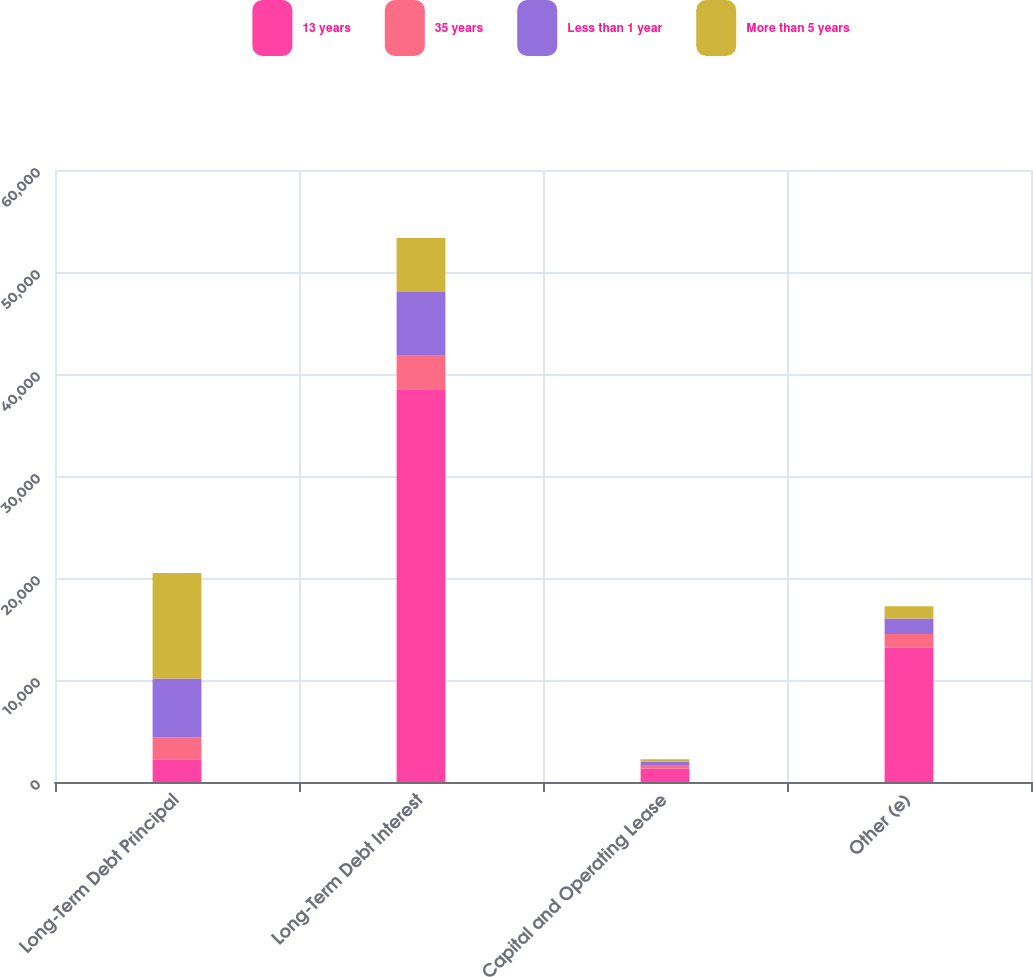Convert chart. <chart><loc_0><loc_0><loc_500><loc_500><stacked_bar_chart><ecel><fcel>Long-Term Debt Principal<fcel>Long-Term Debt Interest<fcel>Capital and Operating Lease<fcel>Other (e)<nl><fcel>13 years<fcel>2197<fcel>38508<fcel>1324<fcel>13187<nl><fcel>35 years<fcel>2197<fcel>3275<fcel>259<fcel>1334<nl><fcel>Less than 1 year<fcel>5743<fcel>6247<fcel>405<fcel>1514<nl><fcel>More than 5 years<fcel>10344<fcel>5314<fcel>250<fcel>1203<nl></chart> 